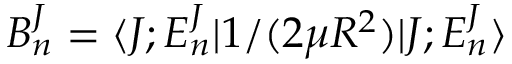Convert formula to latex. <formula><loc_0><loc_0><loc_500><loc_500>B _ { n } ^ { J } = \langle J ; E _ { n } ^ { J } | 1 / ( 2 \mu R ^ { 2 } ) | J ; E _ { n } ^ { J } \rangle</formula> 